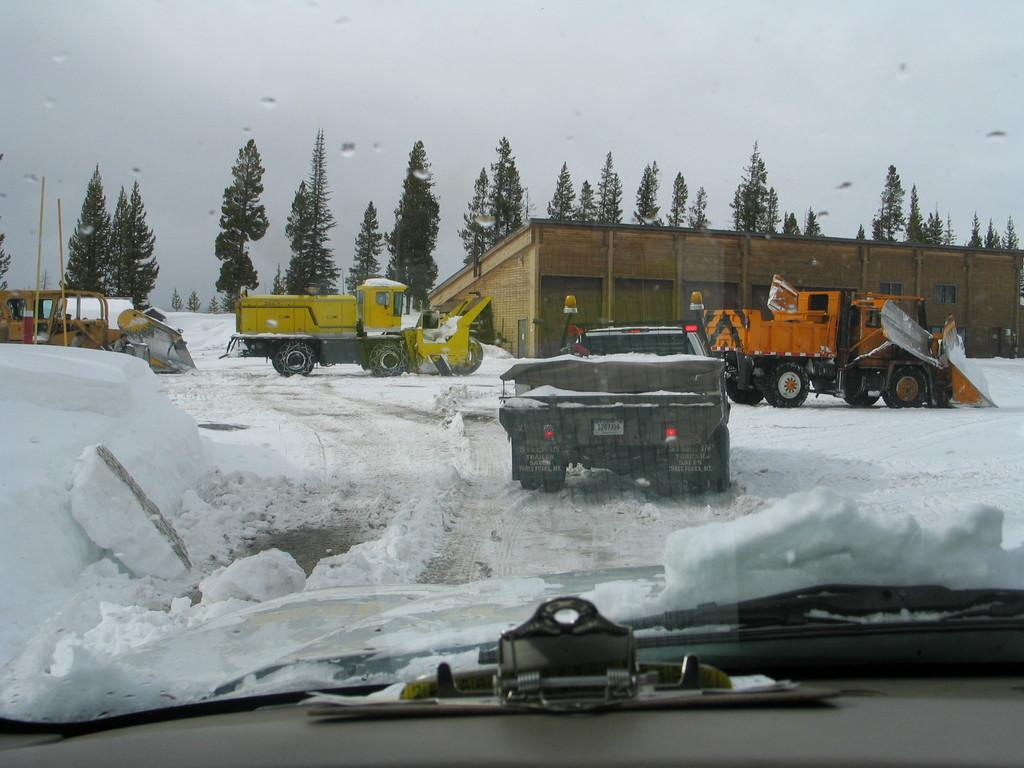What is covering the ground in the image? There is snow on the ground in the image. What type of vehicles can be seen in the image? There are trucks in the image. What type of building is present in the image? There is a house in the image. What type of vegetation is visible in the image? There are green color trees in the image. What is the condition of the sky in the image? The sky is visible at the top of the image and is cloudy. What advice does the snow give to the trucks in the image? There is no indication in the image that the snow or any other element is providing advice to the trucks. What year does the image depict? The image does not provide any information about the year it depicts. 